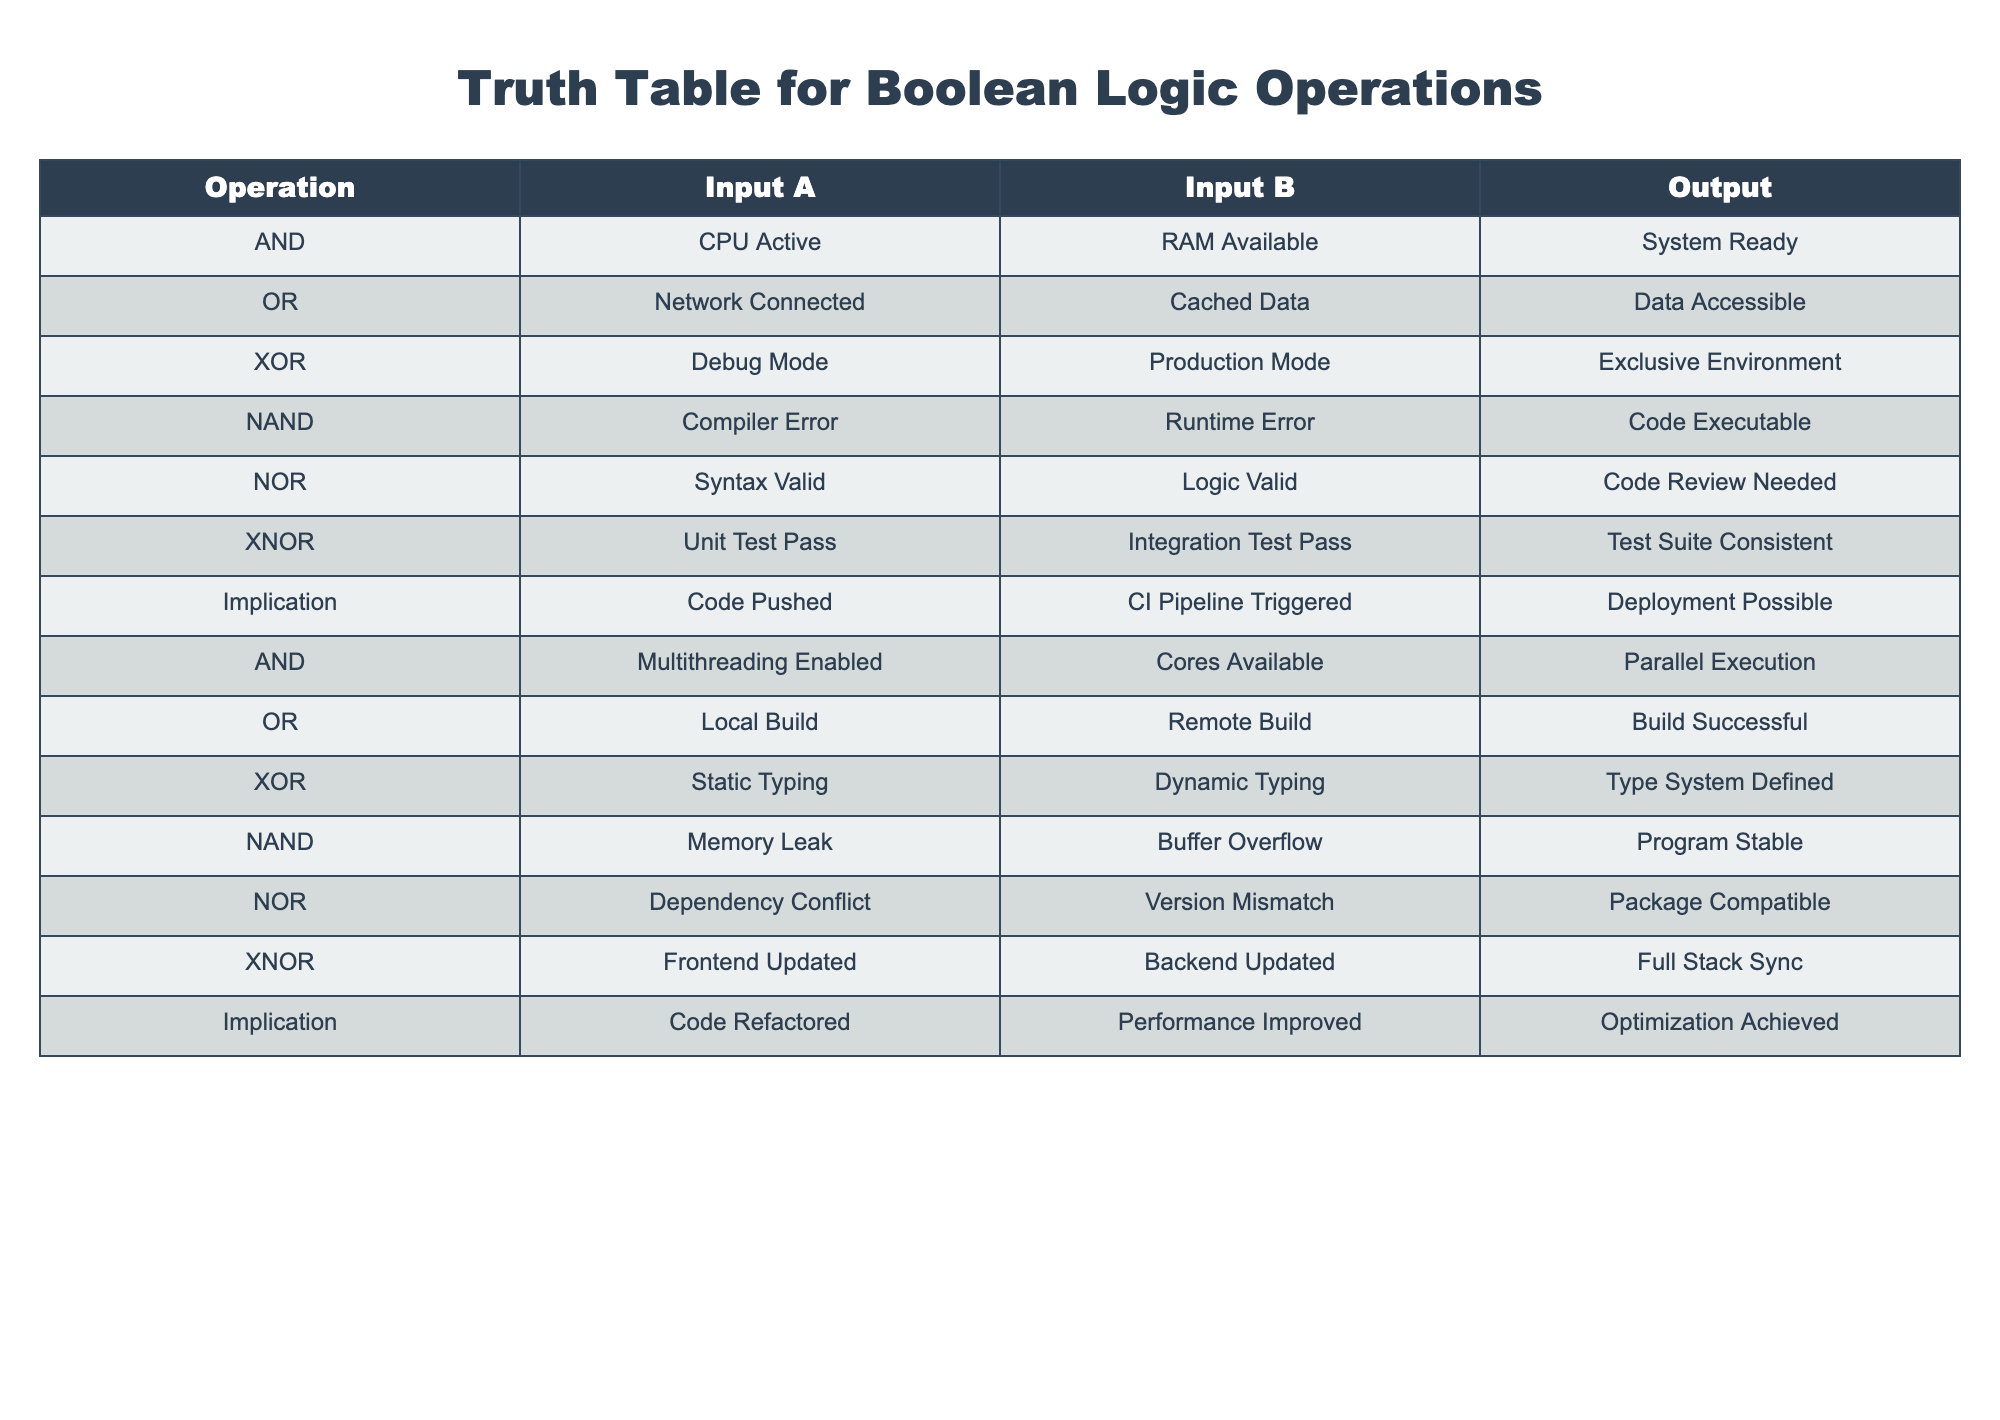What is the output when both inputs are 'CPU Active' and 'RAM Available'? Referring to the table, when the operation is AND and both inputs are 'CPU Active' and 'RAM Available', the output is 'System Ready'.
Answer: System Ready Which operation indicates that when a 'Memory Leak' occurs, the program is still 'Stable'? By checking the NAND operation row, when 'Memory Leak' and 'Buffer Overflow' are inputs, the output states that the program is 'Stable'.
Answer: Yes How many operations result in a condition where both inputs must be true in order for an output indicating success to occur? The operations that require both inputs to be true for a positive output are AND. There are two instances of AND in the table, showing different contexts for success.
Answer: 2 Is 'Code Review Needed' produced by a combination of both 'Syntax Valid' and 'Logic Valid'? Looking at the NOR operation, when the inputs are 'Syntax Valid' and 'Logic Valid', the output clearly states that 'Code Review Needed' is the result.
Answer: Yes Which two operations have outputs related to testing consistency? The two operations that refer to testing consistency are XNOR and Implication. XNOR relates to tests being consistent while Implication is tied to optimization.
Answer: XNOR and Implication What are the contrasting outputs when 'Static Typing' and 'Dynamic Typing' are compared in their respective operation? In the XOR operation, when comparing 'Static Typing' and 'Dynamic Typing', the output states that 'Type System Defined' emerges from this combination, contrasting other operations.
Answer: Type System Defined If both 'Frontend Updated' and 'Backend Updated', what is the outcome inferred from the logic operation used? Looking into the XNOR operation, having both 'Frontend Updated' and 'Backend Updated' leads to an output of 'Test Suite Consistent'. This indicates harmony between both updates.
Answer: Test Suite Consistent Given that 'Code Refactored' and 'Performance Improved', what is the conditional implication present in the language context? The Implication operation shows that when 'Code Refactored' is true, it implies that 'Performance Improved', leading to a potential outcome of 'Optimization Achieved'.
Answer: Optimization Achieved For what combined conditions does the output state 'Data Accessible'? The OR operation specifies that if either 'Network Connected' or 'Cached Data' is true, the output will result in 'Data Accessible', highlighting the flexibility of access.
Answer: Data Accessible 